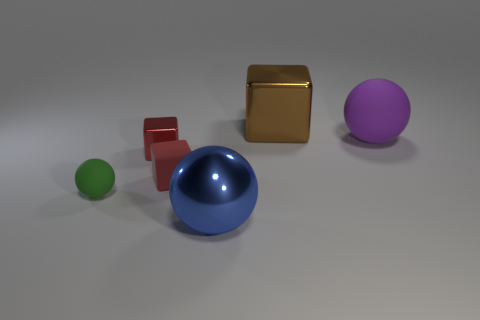Do the rubber cube and the shiny cube in front of the purple ball have the same color?
Provide a short and direct response. Yes. There is a large blue object on the left side of the big shiny thing behind the small shiny cube; what is its shape?
Provide a succinct answer. Sphere. Does the green thing have the same material as the large sphere that is behind the small green matte object?
Offer a terse response. Yes. What shape is the rubber thing that is the same color as the tiny metallic object?
Offer a terse response. Cube. What number of purple matte things have the same size as the green sphere?
Your answer should be very brief. 0. Are there fewer purple objects in front of the tiny red rubber block than tiny blue matte cubes?
Your answer should be very brief. No. There is a small green matte sphere; what number of matte cubes are to the right of it?
Give a very brief answer. 1. There is a matte ball on the right side of the large metal thing behind the large sphere that is in front of the tiny red metal cube; how big is it?
Your response must be concise. Large. Do the large rubber thing and the large object that is in front of the small green ball have the same shape?
Give a very brief answer. Yes. There is a blue ball that is the same material as the big block; what size is it?
Give a very brief answer. Large. 